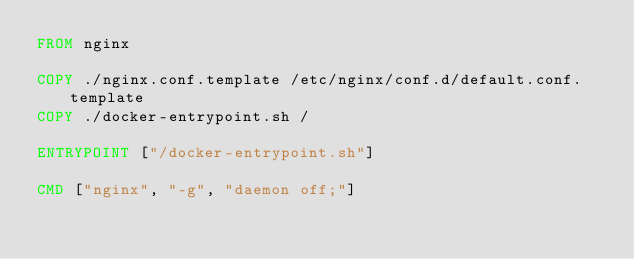<code> <loc_0><loc_0><loc_500><loc_500><_Dockerfile_>FROM nginx

COPY ./nginx.conf.template /etc/nginx/conf.d/default.conf.template
COPY ./docker-entrypoint.sh /

ENTRYPOINT ["/docker-entrypoint.sh"]

CMD ["nginx", "-g", "daemon off;"]
</code> 